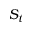<formula> <loc_0><loc_0><loc_500><loc_500>S _ { t }</formula> 